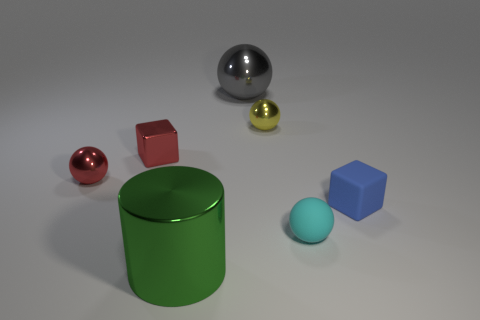Subtract all purple spheres. Subtract all yellow cylinders. How many spheres are left? 4 Add 1 brown metallic cylinders. How many objects exist? 8 Subtract all cylinders. How many objects are left? 6 Subtract 1 red spheres. How many objects are left? 6 Subtract all purple metal cylinders. Subtract all yellow metallic objects. How many objects are left? 6 Add 7 tiny cyan rubber spheres. How many tiny cyan rubber spheres are left? 8 Add 6 tiny purple shiny objects. How many tiny purple shiny objects exist? 6 